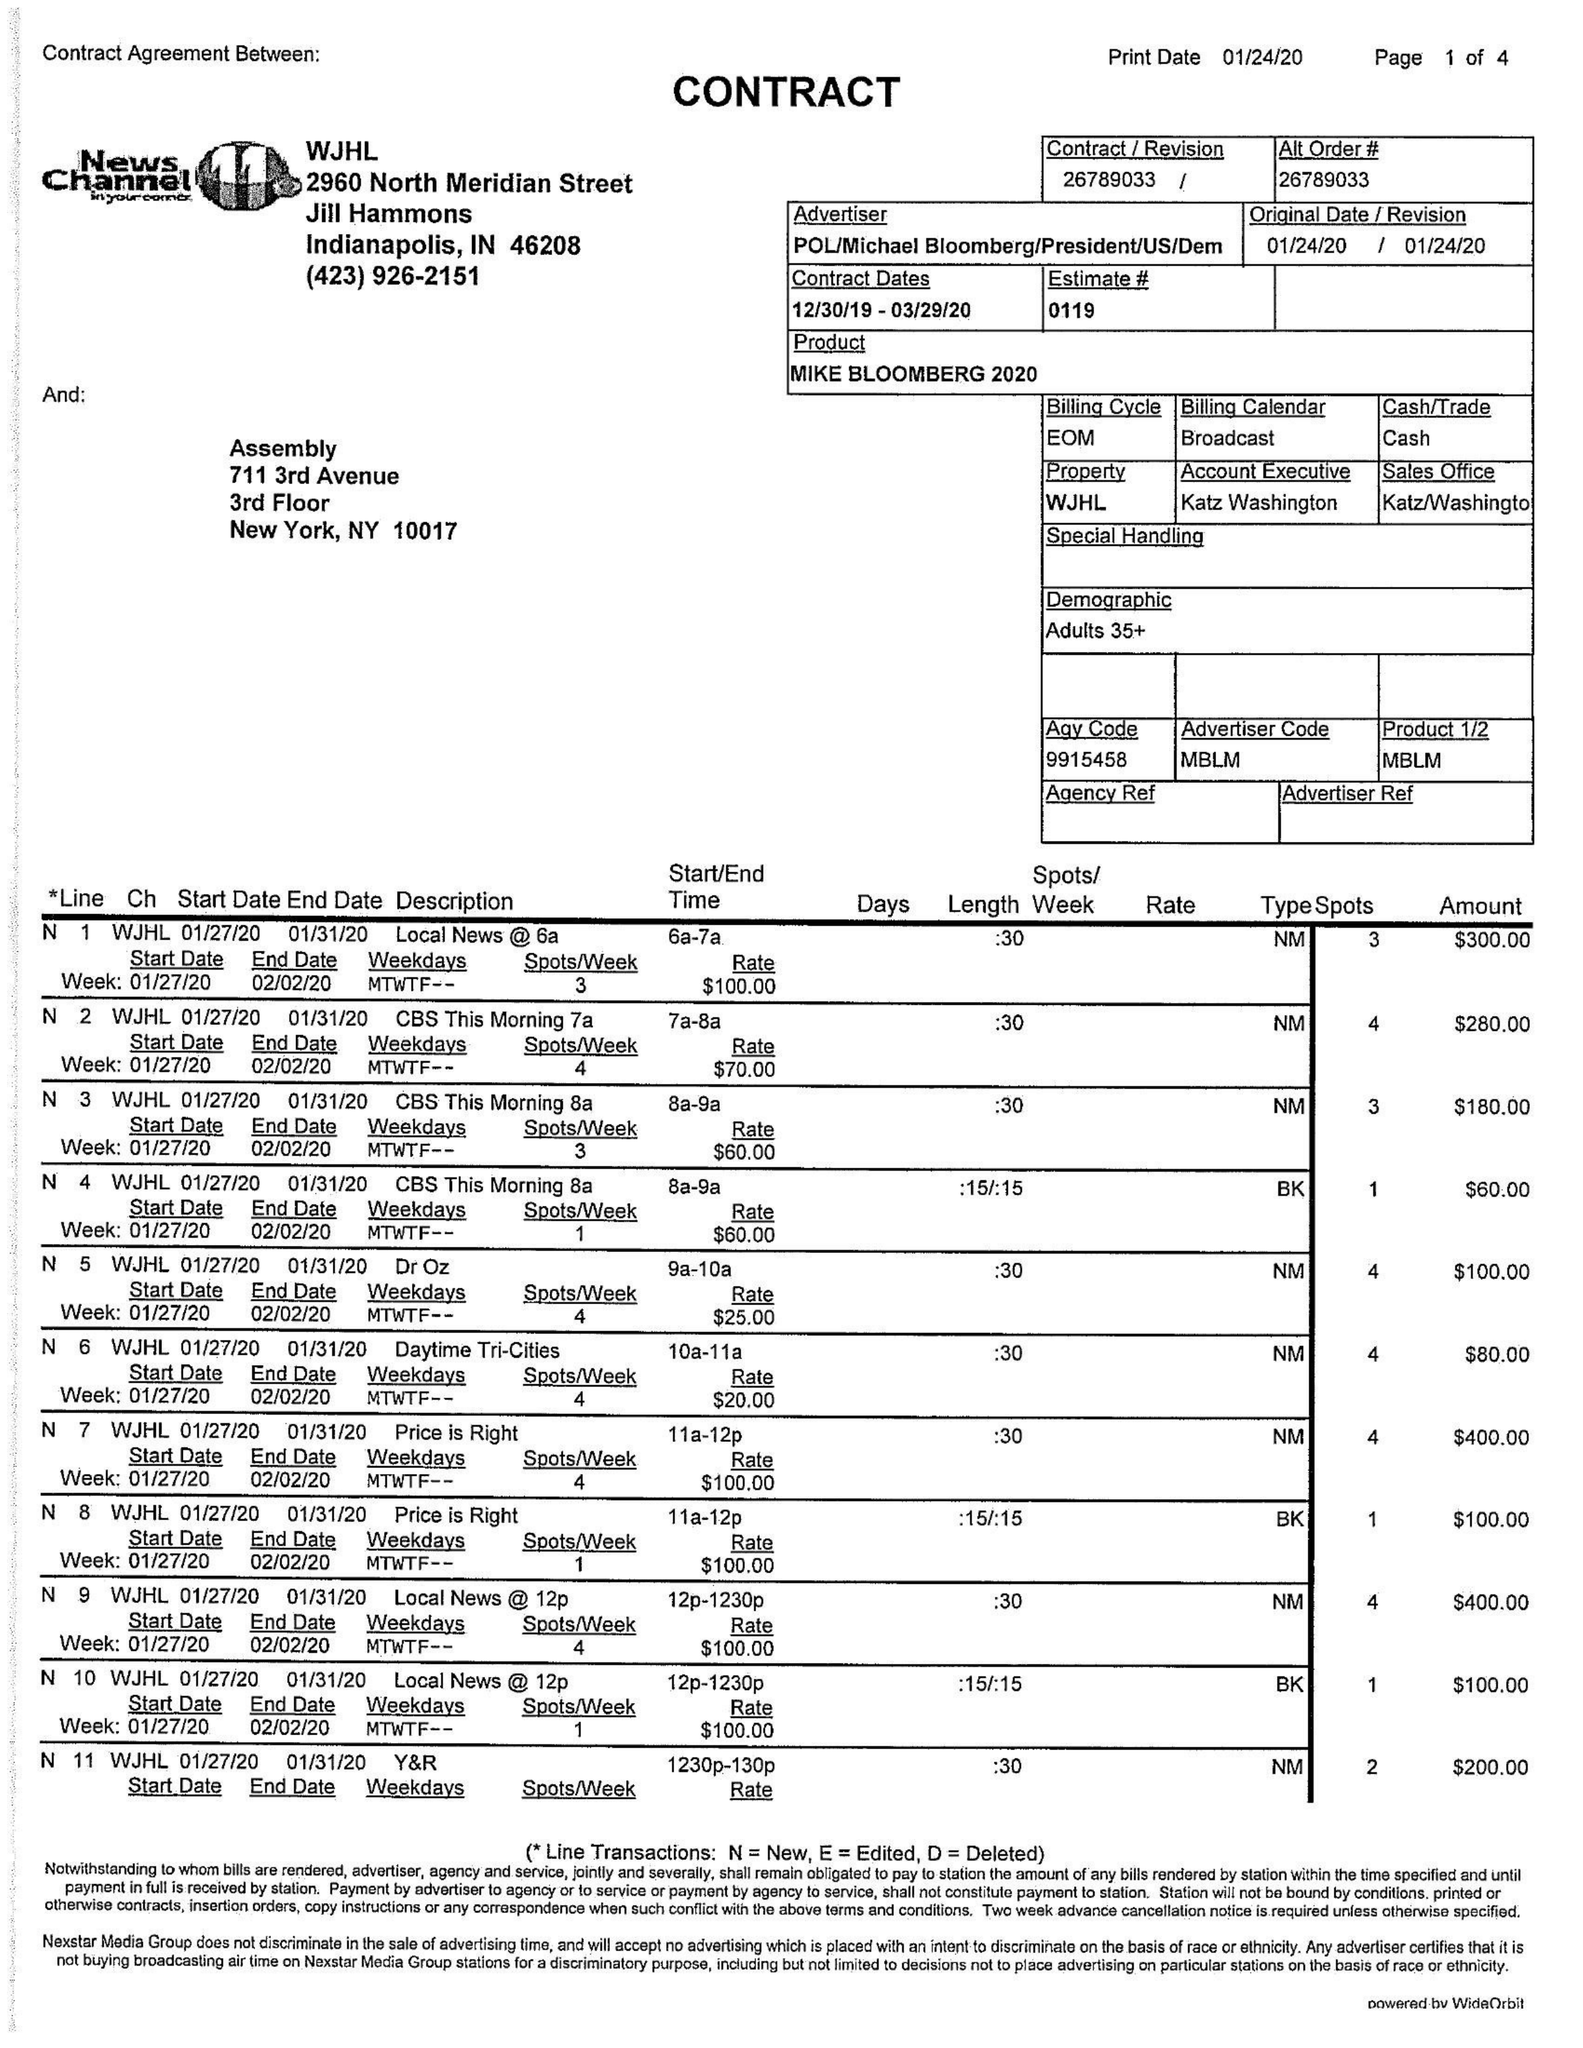What is the value for the contract_num?
Answer the question using a single word or phrase. 26789033 